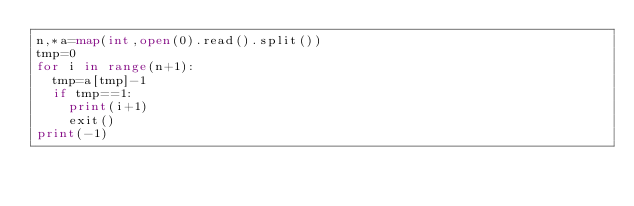<code> <loc_0><loc_0><loc_500><loc_500><_Python_>n,*a=map(int,open(0).read().split())
tmp=0
for i in range(n+1):
  tmp=a[tmp]-1
  if tmp==1:
    print(i+1)
    exit()
print(-1)</code> 